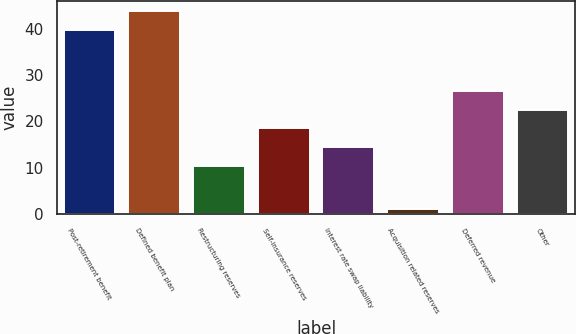Convert chart. <chart><loc_0><loc_0><loc_500><loc_500><bar_chart><fcel>Post-retirement benefit<fcel>Defined benefit plan<fcel>Restructuring reserves<fcel>Self-insurance reserves<fcel>Interest rate swap liability<fcel>Acquisition related reserves<fcel>Deferred revenue<fcel>Other<nl><fcel>39.7<fcel>43.73<fcel>10.4<fcel>18.46<fcel>14.43<fcel>1.1<fcel>26.52<fcel>22.49<nl></chart> 